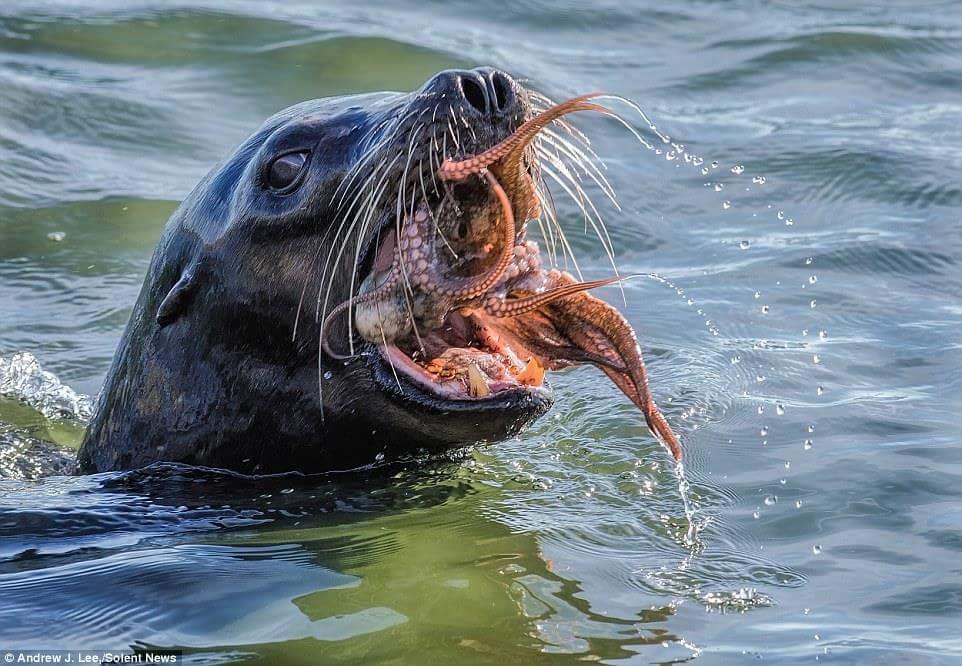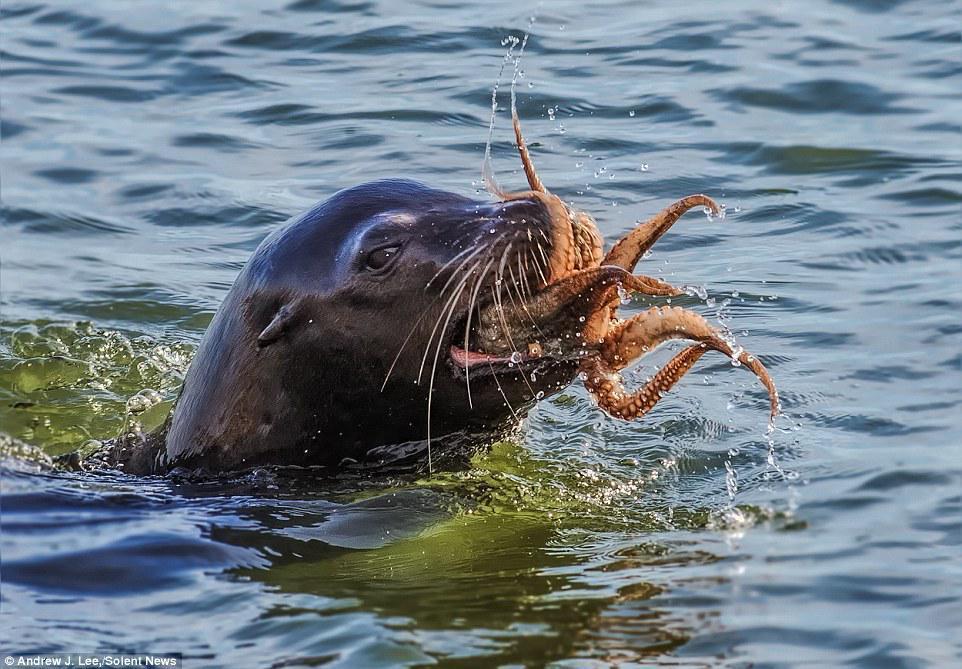The first image is the image on the left, the second image is the image on the right. Evaluate the accuracy of this statement regarding the images: "The squid in in the wide open mouth of the seal in at least one of the images.". Is it true? Answer yes or no. Yes. The first image is the image on the left, the second image is the image on the right. Considering the images on both sides, is "Right image shows a seal with its head above water and octopus legs sticking out of its mouth." valid? Answer yes or no. Yes. 